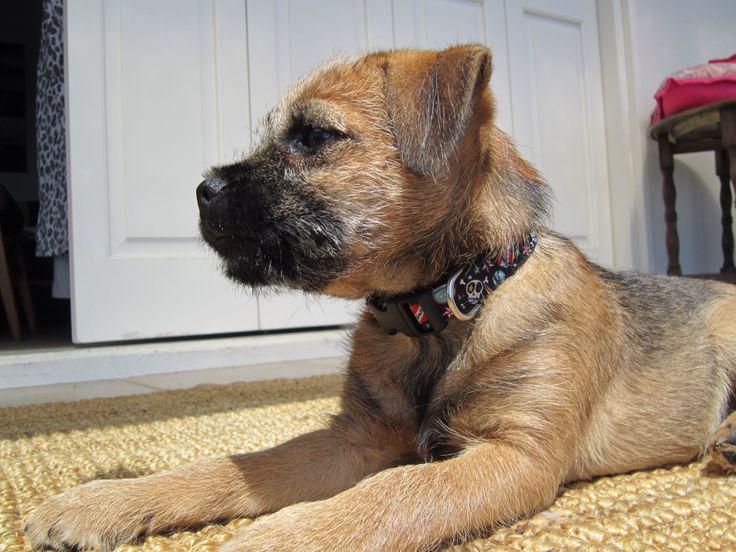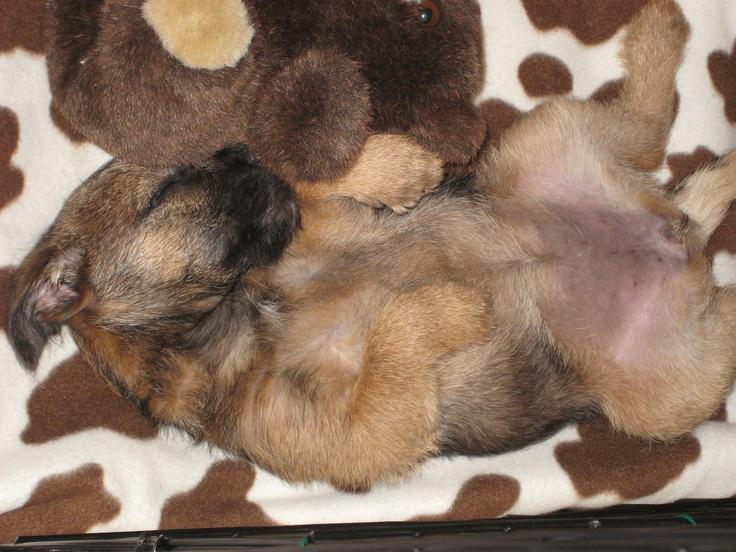The first image is the image on the left, the second image is the image on the right. Assess this claim about the two images: "There are three dogs,  dog on the right is looking straight at the camera, as if making eye contact.". Correct or not? Answer yes or no. No. The first image is the image on the left, the second image is the image on the right. Assess this claim about the two images: "An image shows a dog in a sleeping pose on a patterned fabric.". Correct or not? Answer yes or no. Yes. 